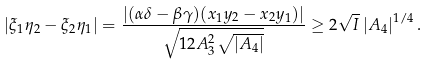<formula> <loc_0><loc_0><loc_500><loc_500>| \xi _ { 1 } \eta _ { 2 } - \xi _ { 2 } \eta _ { 1 } | = \frac { | ( \alpha \delta - \beta \gamma ) ( x _ { 1 } y _ { 2 } - x _ { 2 } y _ { 1 } ) | } { \sqrt { 1 2 A _ { 3 } ^ { 2 } \sqrt { \left | A _ { 4 } \right | } } } \geq 2 \sqrt { I } \left | A _ { 4 } \right | ^ { 1 / 4 } .</formula> 